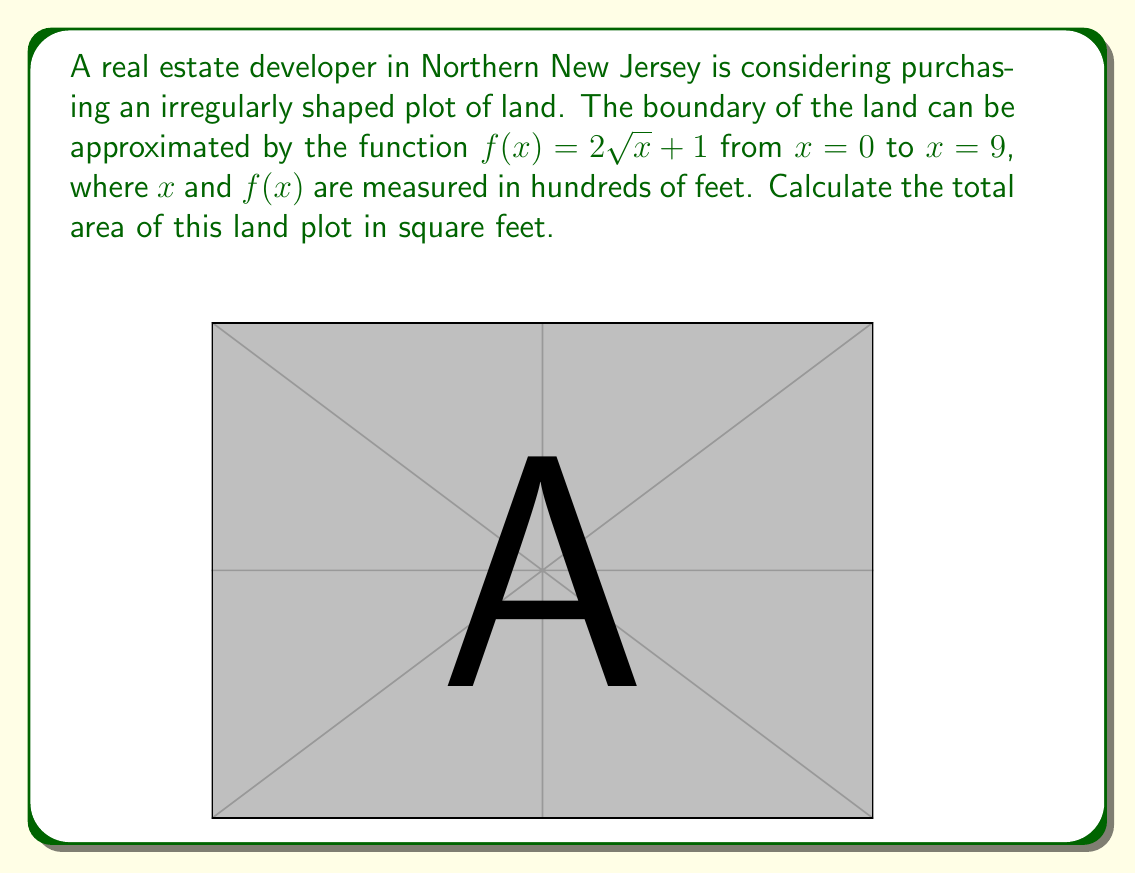Show me your answer to this math problem. To find the area of this irregularly shaped land plot, we need to use integration. The area under a curve $f(x)$ from $a$ to $b$ is given by the definite integral:

$$ A = \int_a^b f(x) dx $$

In this case, we have:
$f(x) = 2\sqrt{x} + 1$
$a = 0$
$b = 9$

So, our integral becomes:

$$ A = \int_0^9 (2\sqrt{x} + 1) dx $$

Let's solve this integral step by step:

1) First, let's separate the integral:
   $$ A = \int_0^9 2\sqrt{x} dx + \int_0^9 1 dx $$

2) For the first part, we can use the power rule of integration with $u$-substitution:
   Let $u = \sqrt{x}$, then $x = u^2$ and $dx = 2u du$
   $$ \int 2\sqrt{x} dx = \int 2u \cdot 2u du = 4\int u^2 du = \frac{4}{3}u^3 + C = \frac{4}{3}(\sqrt{x})^3 + C $$

3) The second part is simply the integral of a constant:
   $$ \int 1 dx = x + C $$

4) Now, let's put it all together and evaluate from 0 to 9:

   $$ A = \left[ \frac{4}{3}(\sqrt{x})^3 + x \right]_0^9 $$
   $$ = \left( \frac{4}{3}(3)^3 + 9 \right) - \left( \frac{4}{3}(0)^3 + 0 \right) $$
   $$ = (36 + 9) - 0 = 45 $$

5) Remember that $x$ was measured in hundreds of feet, so we need to multiply our result by 100^2 to get square feet:

   $$ A = 45 \cdot 100^2 = 450,000 \text{ sq ft} $$
Answer: The total area of the land plot is 450,000 square feet. 